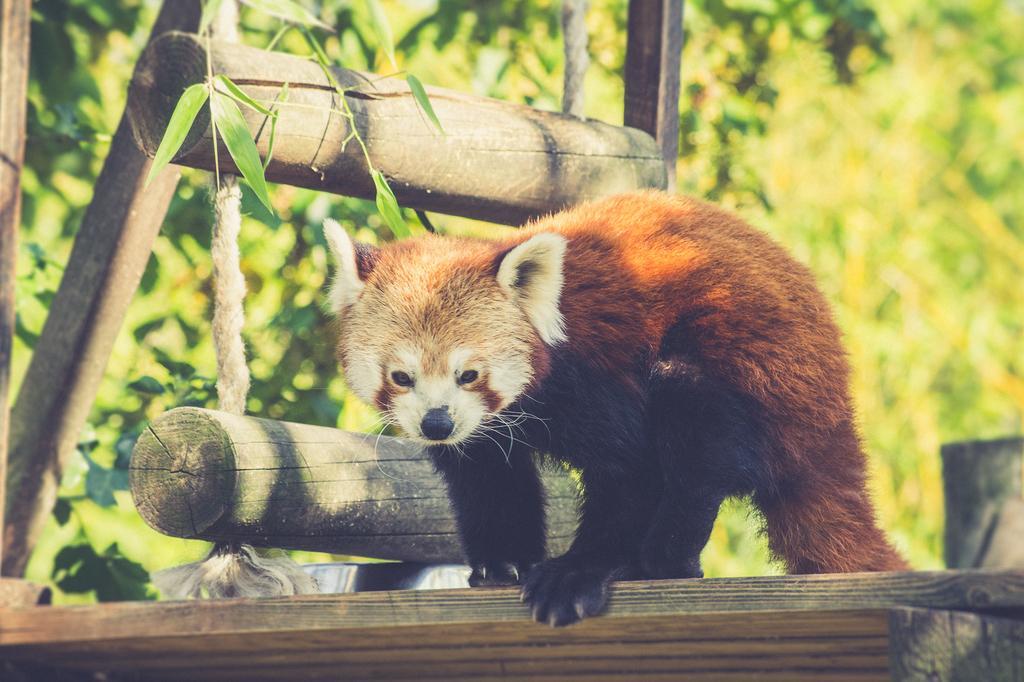How would you summarize this image in a sentence or two? In the center of the image, we can see an animal on the wood and in the background, there is a rope ladder and we can see some sticks and trees. 